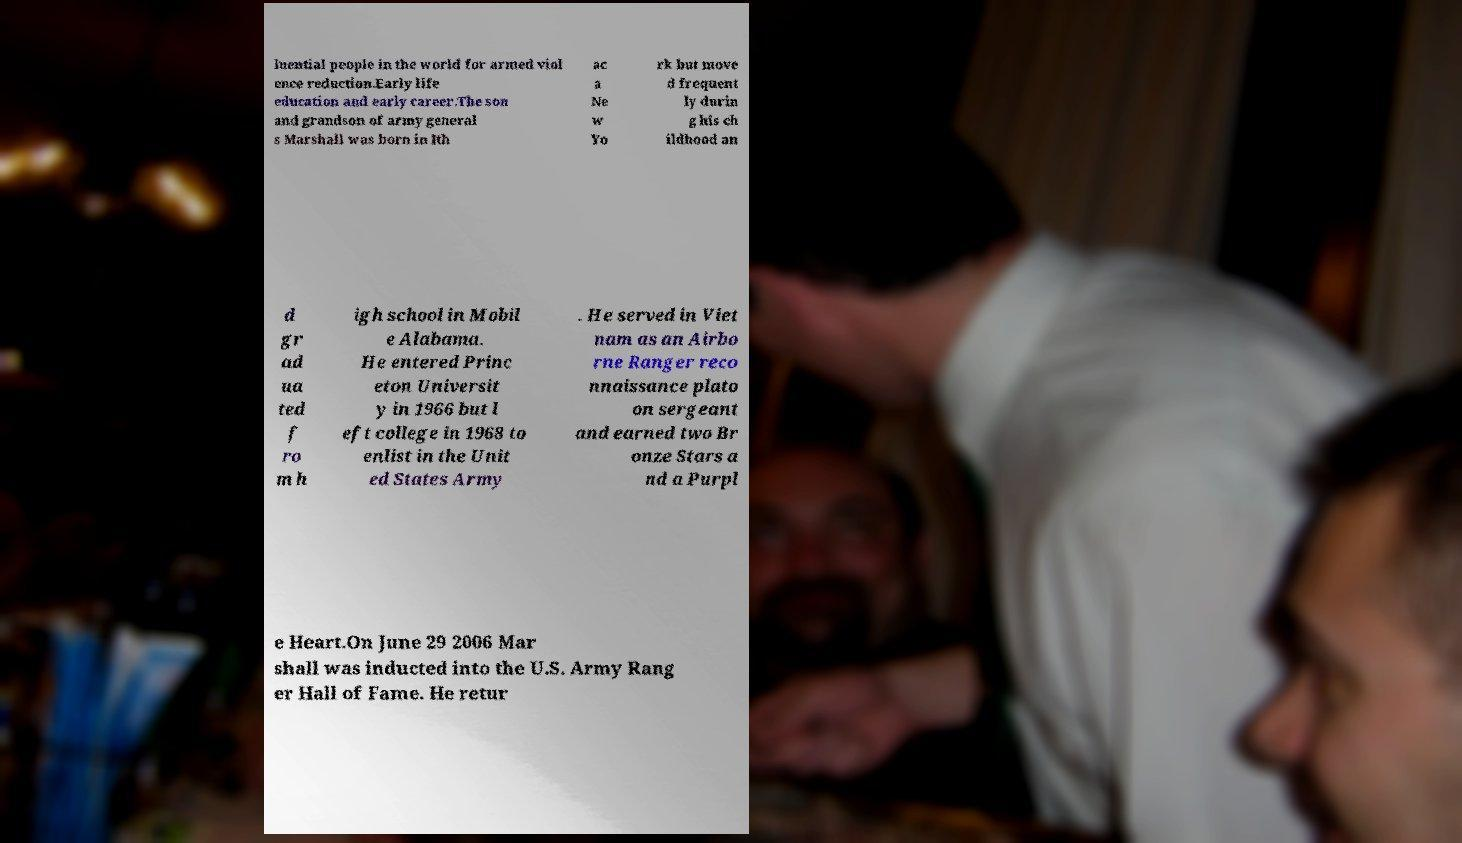For documentation purposes, I need the text within this image transcribed. Could you provide that? luential people in the world for armed viol ence reduction.Early life education and early career.The son and grandson of army general s Marshall was born in Ith ac a Ne w Yo rk but move d frequent ly durin g his ch ildhood an d gr ad ua ted f ro m h igh school in Mobil e Alabama. He entered Princ eton Universit y in 1966 but l eft college in 1968 to enlist in the Unit ed States Army . He served in Viet nam as an Airbo rne Ranger reco nnaissance plato on sergeant and earned two Br onze Stars a nd a Purpl e Heart.On June 29 2006 Mar shall was inducted into the U.S. Army Rang er Hall of Fame. He retur 